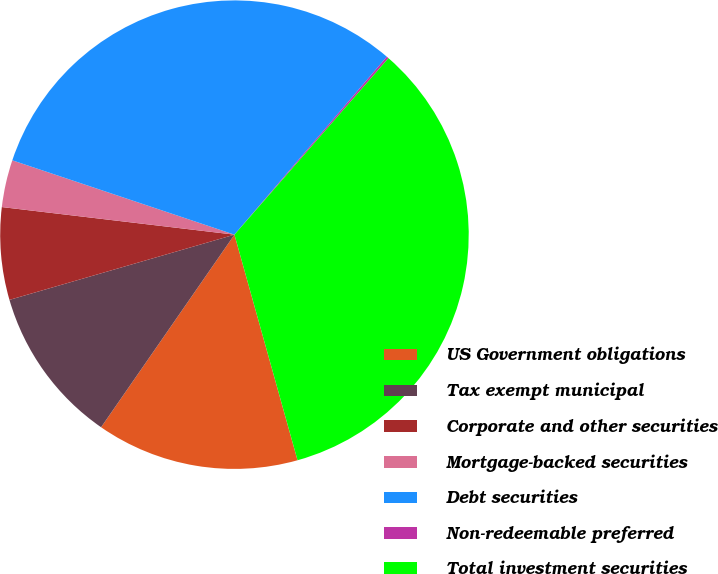Convert chart to OTSL. <chart><loc_0><loc_0><loc_500><loc_500><pie_chart><fcel>US Government obligations<fcel>Tax exempt municipal<fcel>Corporate and other securities<fcel>Mortgage-backed securities<fcel>Debt securities<fcel>Non-redeemable preferred<fcel>Total investment securities<nl><fcel>13.98%<fcel>10.87%<fcel>6.37%<fcel>3.26%<fcel>31.13%<fcel>0.15%<fcel>34.24%<nl></chart> 